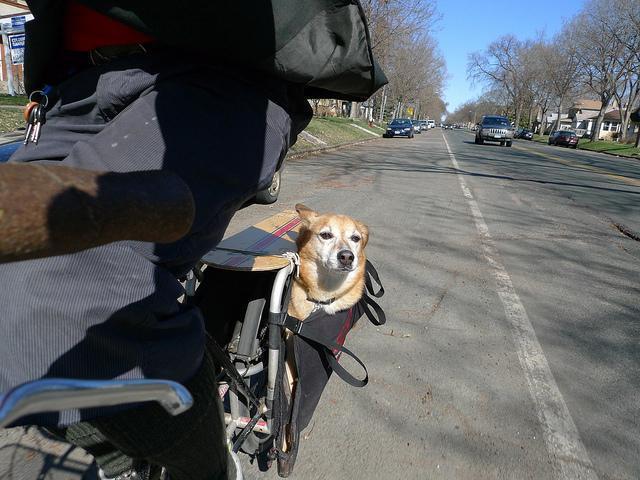How many ears are visible?
Give a very brief answer. 1. How many people can be seen?
Give a very brief answer. 2. How many zebras are drinking water?
Give a very brief answer. 0. 